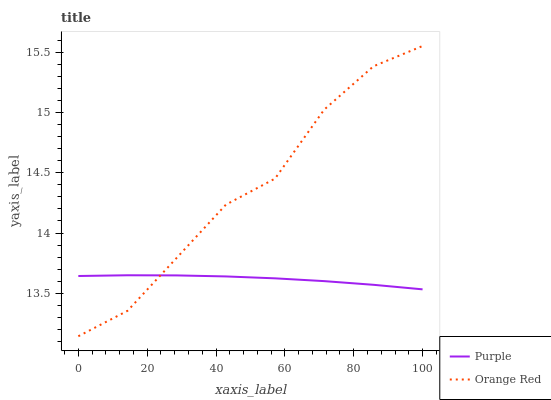Does Purple have the minimum area under the curve?
Answer yes or no. Yes. Does Orange Red have the maximum area under the curve?
Answer yes or no. Yes. Does Orange Red have the minimum area under the curve?
Answer yes or no. No. Is Purple the smoothest?
Answer yes or no. Yes. Is Orange Red the roughest?
Answer yes or no. Yes. Is Orange Red the smoothest?
Answer yes or no. No. Does Orange Red have the highest value?
Answer yes or no. Yes. Does Purple intersect Orange Red?
Answer yes or no. Yes. Is Purple less than Orange Red?
Answer yes or no. No. Is Purple greater than Orange Red?
Answer yes or no. No. 